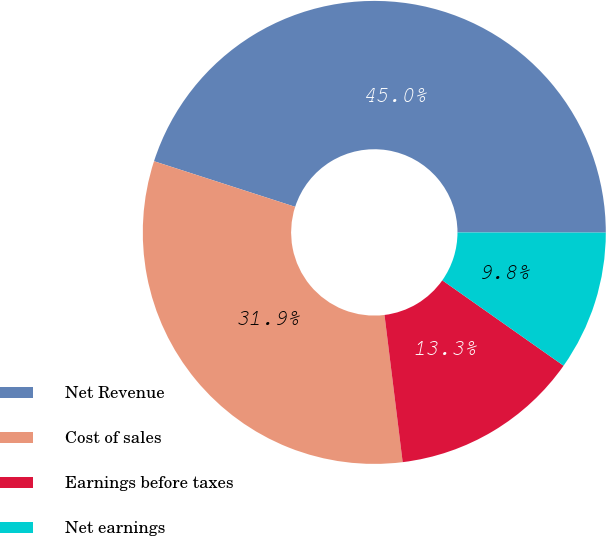Convert chart to OTSL. <chart><loc_0><loc_0><loc_500><loc_500><pie_chart><fcel>Net Revenue<fcel>Cost of sales<fcel>Earnings before taxes<fcel>Net earnings<nl><fcel>45.04%<fcel>31.93%<fcel>13.28%<fcel>9.75%<nl></chart> 